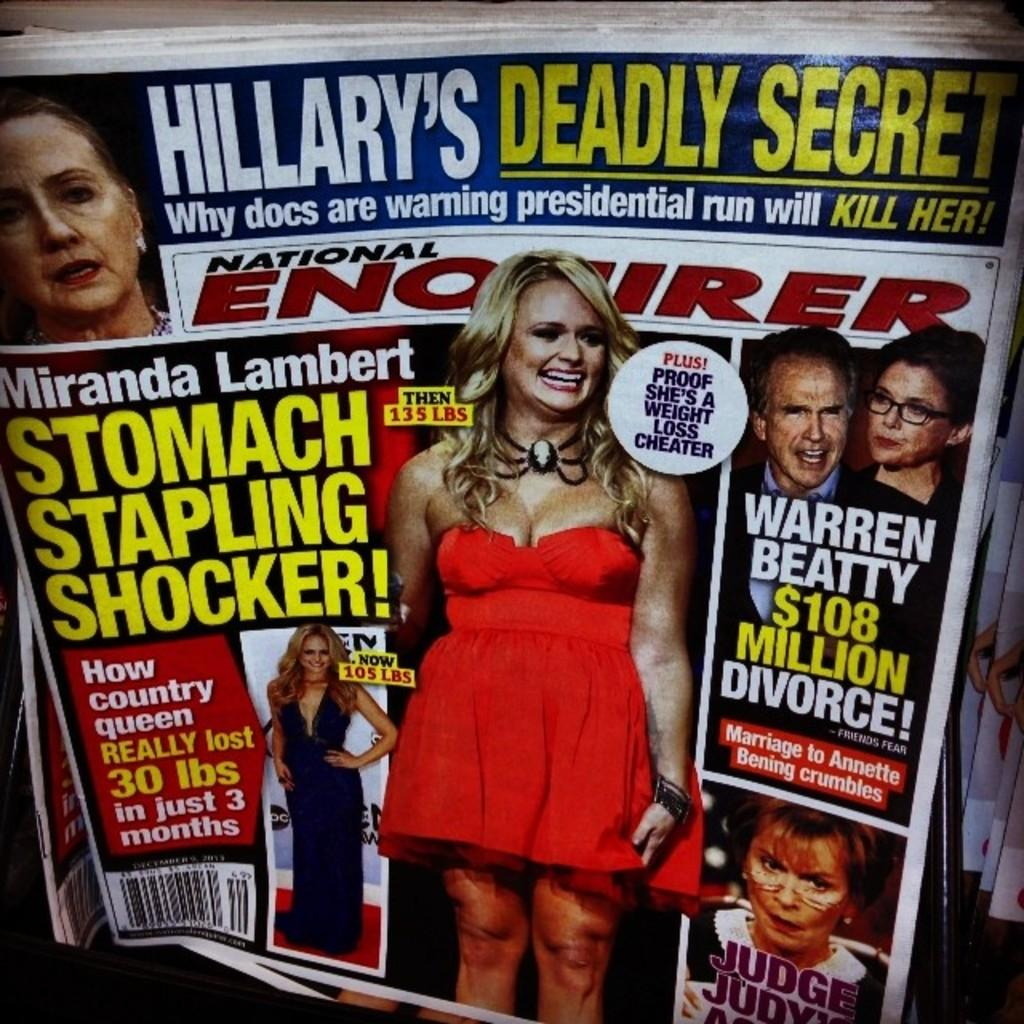What type of printed material is present in the image? There are magazines in the image. What can be found within the magazines? There are pictures of people in the magazines. What else is visible in the image besides the magazines? There is writing in the image. Can you describe the facial expressions of some people in the images? Some faces in the images have a smile. What type of trousers are the people wearing in the image? There is no information about the clothing of the people in the image, as it only mentions pictures of people and their facial expressions. --- 